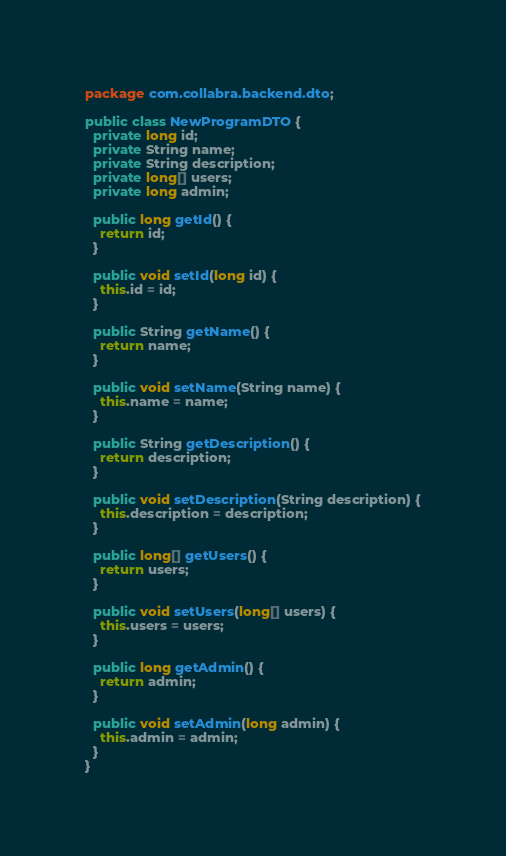<code> <loc_0><loc_0><loc_500><loc_500><_Java_>package com.collabra.backend.dto;

public class NewProgramDTO {
  private long id;
  private String name;
  private String description;
  private long[] users;
  private long admin;

  public long getId() {
    return id;
  }
  
  public void setId(long id) {
    this.id = id;
  }
  
  public String getName() {
    return name;
  }
  
  public void setName(String name) {
    this.name = name;
  }
  
  public String getDescription() {
    return description;
  }
  
  public void setDescription(String description) {
    this.description = description;
  }

  public long[] getUsers() {
    return users;
  }

  public void setUsers(long[] users) {
    this.users = users;
  }

  public long getAdmin() {
    return admin;
  }

  public void setAdmin(long admin) {
    this.admin = admin;
  }
}
</code> 